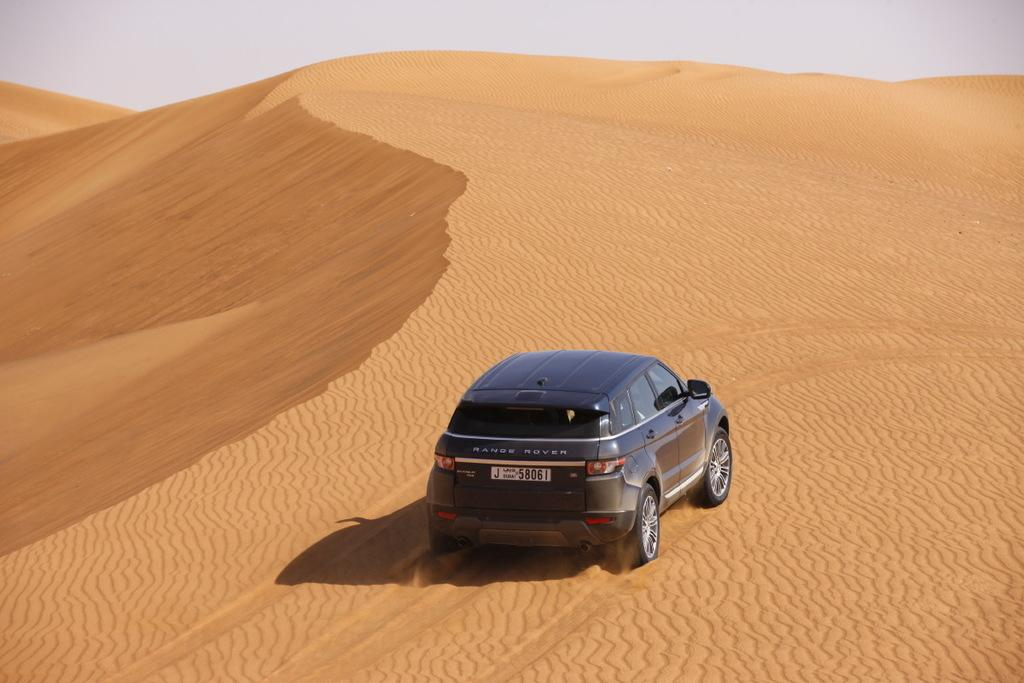What is the main subject of the image? There is a car in the image. Where is the car located? The car is on the sand. What can be seen in the background of the image? There is sky visible in the background of the image. What type of yarn is being used to create the trail in the image? There is no trail or yarn present in the image; it features a car on the sand with sky visible in the background. 